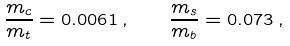Convert formula to latex. <formula><loc_0><loc_0><loc_500><loc_500>\frac { m _ { c } } { m _ { t } } = 0 . 0 0 6 1 \, , \quad \frac { m _ { s } } { m _ { b } } = 0 . 0 7 3 \, ,</formula> 